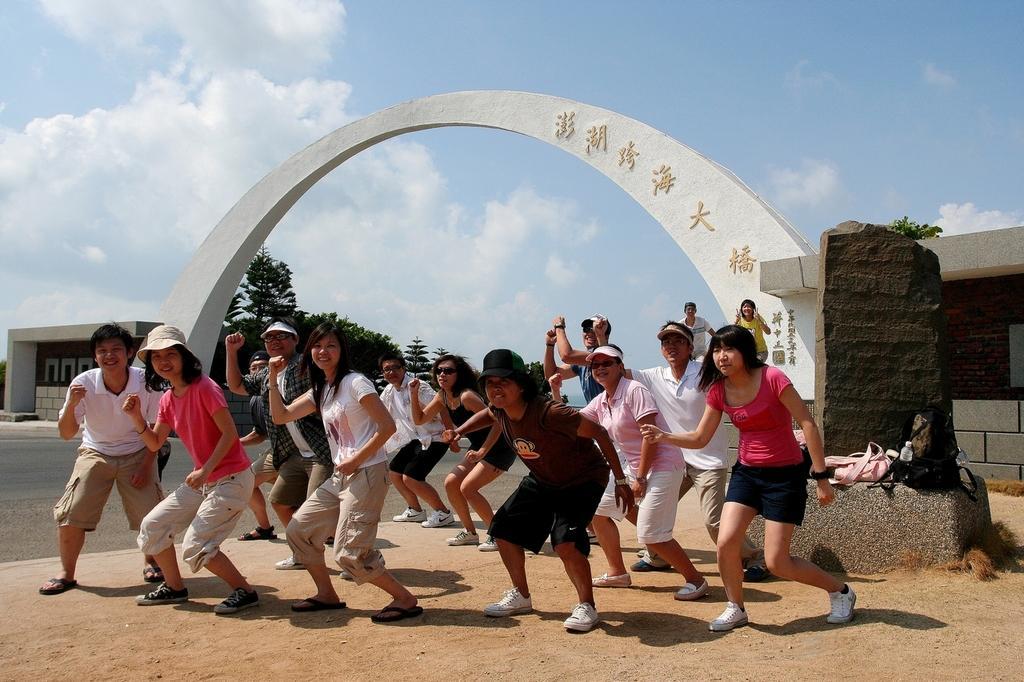Describe this image in one or two sentences. In the foreground of the picture we can see e group of people, soil, foundation stone, bags, grass and road. In the middle of the picture there are trees, arch and wall. In the background it is sky. 